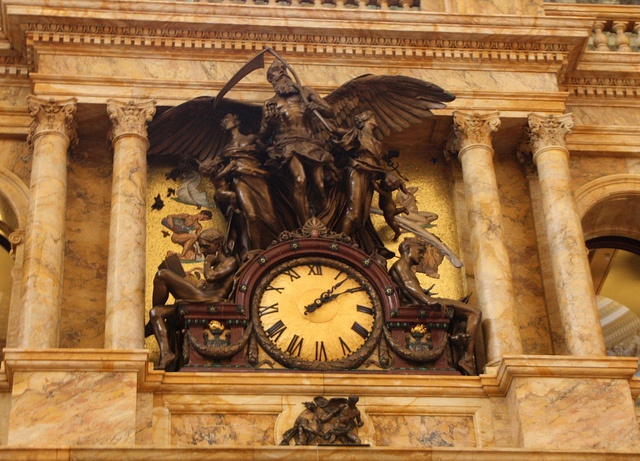Describe the objects in this image and their specific colors. I can see a clock in brown, gold, orange, and maroon tones in this image. 